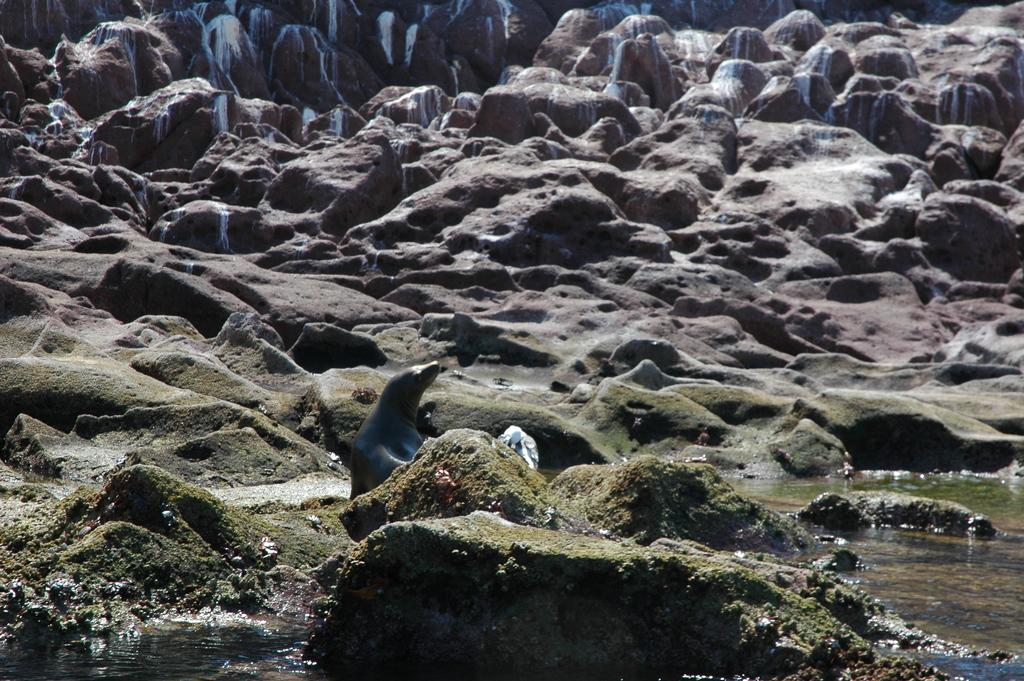What type of animal is in the image? There is a penguin in the image. What is at the bottom of the image? There is water at the bottom of the image. What is in the middle of the image? There is sand in the middle of the image. What geographical feature is in the image? There is a mountain in the image. How many snakes are slithering through the farm in the image? There are no snakes or farms present in the image; it features a penguin, water, sand, and a mountain. 